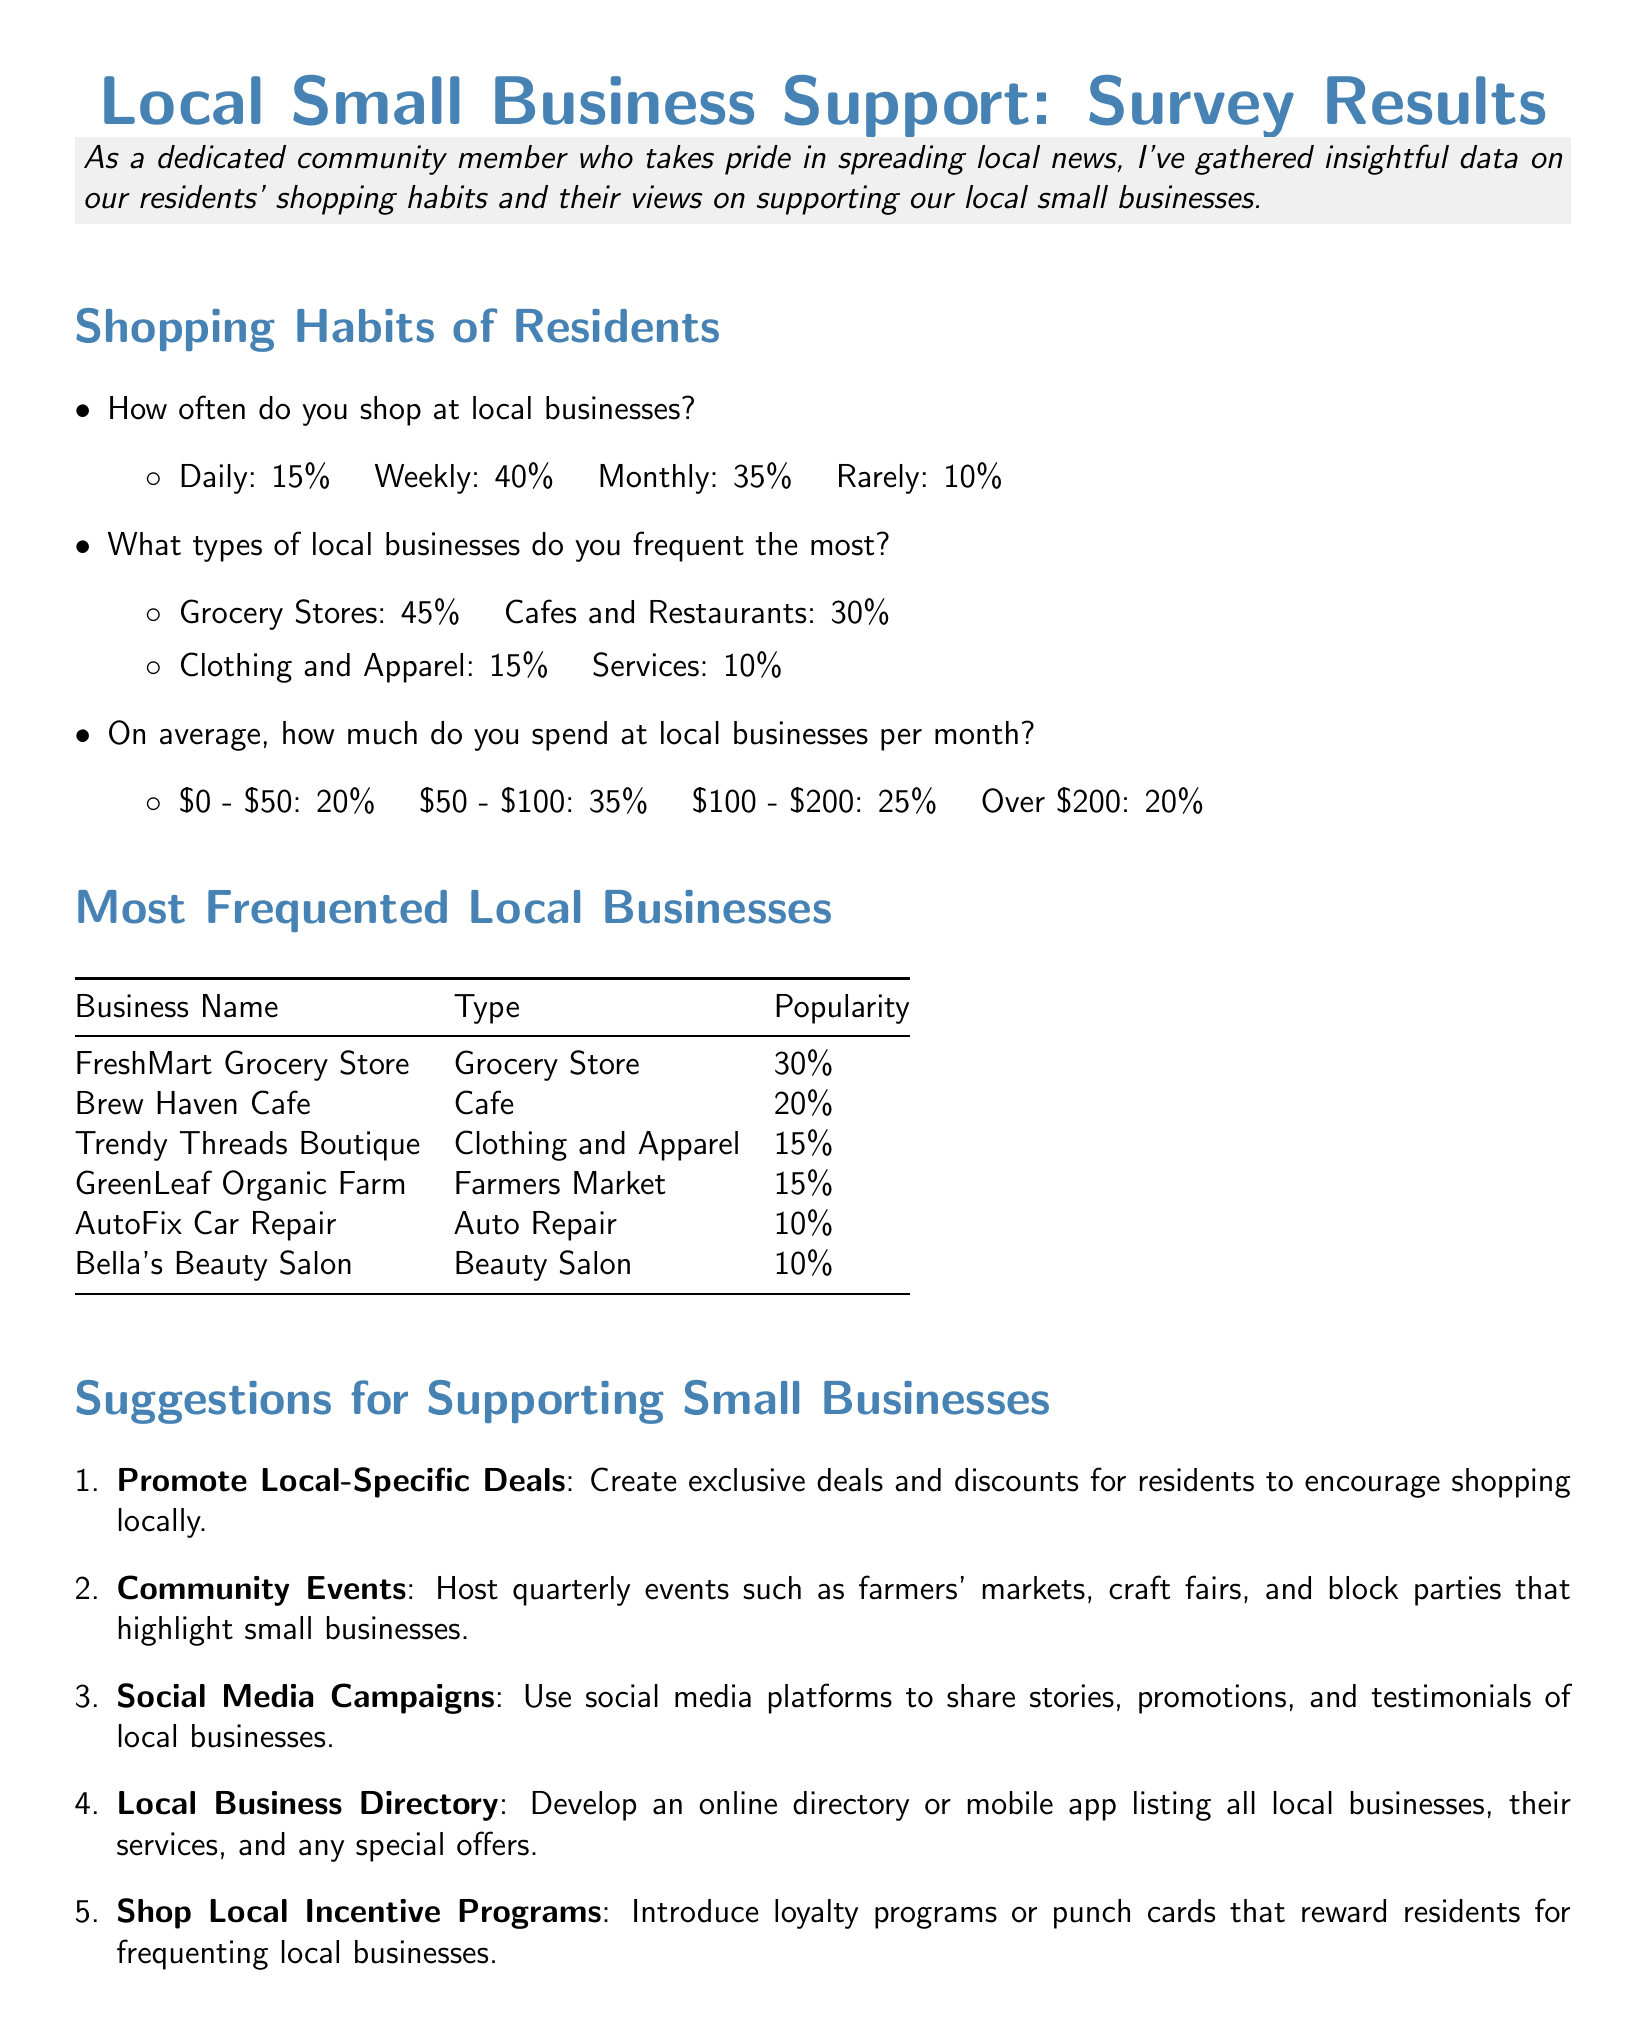How often do residents shop at local businesses? This information is found in the section discussing the shopping habits of residents, detailing their shopping frequency.
Answer: Daily: 15% What is the most frequented type of local business? This information is revealed in the list of types of local businesses frequented by residents, showing their preferences.
Answer: Grocery Stores: 45% What percentage of residents spend between \$50 and \$100 at local businesses? This data is presented in the average spending habits section, which breaks down residents' monthly spending.
Answer: 35% Which grocery store is the most popular among locals? This refers to the table of the most frequented local businesses, identifying the leading business.
Answer: FreshMart Grocery Store What is one suggestion for supporting small businesses? This can be derived from the suggestions section that lists various ideas for community support of local enterprises.
Answer: Promote Local-Specific Deals 